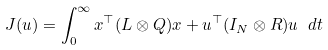<formula> <loc_0><loc_0><loc_500><loc_500>J ( u ) = \int _ { 0 } ^ { \infty } x ^ { \top } ( L \otimes Q ) x + u ^ { \top } ( I _ { N } \otimes R ) u \ d t</formula> 